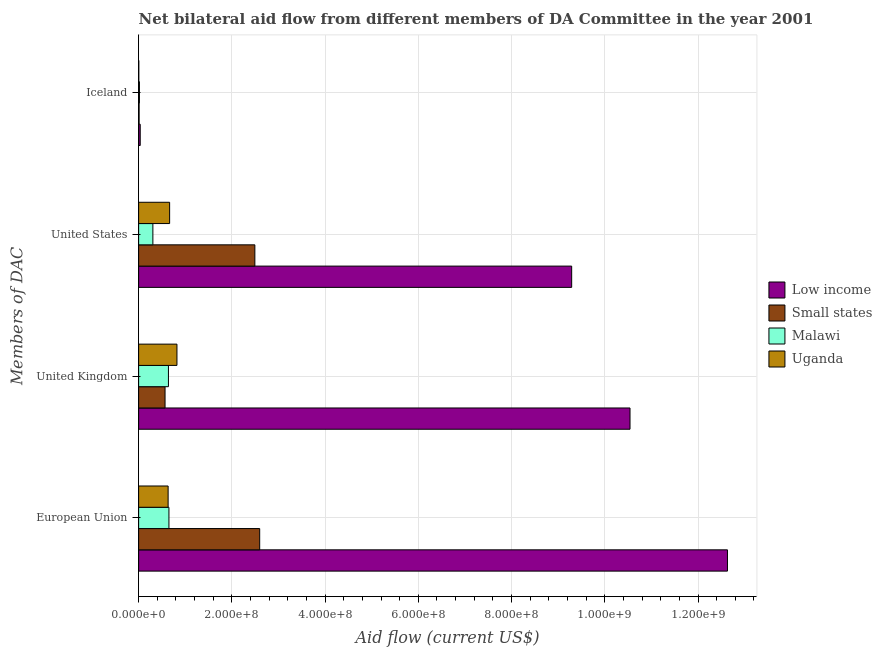How many different coloured bars are there?
Keep it short and to the point. 4. How many groups of bars are there?
Your response must be concise. 4. Are the number of bars per tick equal to the number of legend labels?
Your answer should be compact. Yes. How many bars are there on the 4th tick from the top?
Keep it short and to the point. 4. How many bars are there on the 4th tick from the bottom?
Provide a short and direct response. 4. What is the label of the 2nd group of bars from the top?
Your answer should be very brief. United States. What is the amount of aid given by us in Malawi?
Ensure brevity in your answer.  3.06e+07. Across all countries, what is the maximum amount of aid given by uk?
Keep it short and to the point. 1.05e+09. Across all countries, what is the minimum amount of aid given by us?
Offer a very short reply. 3.06e+07. In which country was the amount of aid given by iceland minimum?
Provide a short and direct response. Uganda. What is the total amount of aid given by iceland in the graph?
Provide a succinct answer. 6.53e+06. What is the difference between the amount of aid given by iceland in Malawi and that in Low income?
Make the answer very short. -1.66e+06. What is the difference between the amount of aid given by iceland in Uganda and the amount of aid given by uk in Low income?
Keep it short and to the point. -1.05e+09. What is the average amount of aid given by eu per country?
Keep it short and to the point. 4.13e+08. What is the difference between the amount of aid given by eu and amount of aid given by us in Low income?
Keep it short and to the point. 3.34e+08. What is the ratio of the amount of aid given by us in Low income to that in Uganda?
Your answer should be compact. 13.97. Is the amount of aid given by uk in Small states less than that in Uganda?
Ensure brevity in your answer.  Yes. What is the difference between the highest and the second highest amount of aid given by iceland?
Ensure brevity in your answer.  1.66e+06. What is the difference between the highest and the lowest amount of aid given by eu?
Provide a short and direct response. 1.20e+09. In how many countries, is the amount of aid given by iceland greater than the average amount of aid given by iceland taken over all countries?
Your answer should be compact. 2. What does the 2nd bar from the top in Iceland represents?
Give a very brief answer. Malawi. What does the 2nd bar from the bottom in Iceland represents?
Make the answer very short. Small states. Is it the case that in every country, the sum of the amount of aid given by eu and amount of aid given by uk is greater than the amount of aid given by us?
Ensure brevity in your answer.  Yes. Are all the bars in the graph horizontal?
Provide a succinct answer. Yes. What is the difference between two consecutive major ticks on the X-axis?
Ensure brevity in your answer.  2.00e+08. Are the values on the major ticks of X-axis written in scientific E-notation?
Your answer should be very brief. Yes. Does the graph contain any zero values?
Your answer should be very brief. No. Does the graph contain grids?
Ensure brevity in your answer.  Yes. Where does the legend appear in the graph?
Give a very brief answer. Center right. What is the title of the graph?
Make the answer very short. Net bilateral aid flow from different members of DA Committee in the year 2001. What is the label or title of the Y-axis?
Give a very brief answer. Members of DAC. What is the Aid flow (current US$) of Low income in European Union?
Your response must be concise. 1.26e+09. What is the Aid flow (current US$) in Small states in European Union?
Your answer should be very brief. 2.60e+08. What is the Aid flow (current US$) in Malawi in European Union?
Your answer should be compact. 6.50e+07. What is the Aid flow (current US$) in Uganda in European Union?
Your answer should be compact. 6.33e+07. What is the Aid flow (current US$) of Low income in United Kingdom?
Your answer should be very brief. 1.05e+09. What is the Aid flow (current US$) of Small states in United Kingdom?
Offer a very short reply. 5.67e+07. What is the Aid flow (current US$) of Malawi in United Kingdom?
Your response must be concise. 6.39e+07. What is the Aid flow (current US$) in Uganda in United Kingdom?
Offer a very short reply. 8.22e+07. What is the Aid flow (current US$) in Low income in United States?
Offer a terse response. 9.29e+08. What is the Aid flow (current US$) of Small states in United States?
Offer a terse response. 2.49e+08. What is the Aid flow (current US$) in Malawi in United States?
Offer a very short reply. 3.06e+07. What is the Aid flow (current US$) in Uganda in United States?
Make the answer very short. 6.65e+07. What is the Aid flow (current US$) of Low income in Iceland?
Provide a short and direct response. 3.40e+06. What is the Aid flow (current US$) in Small states in Iceland?
Offer a very short reply. 1.03e+06. What is the Aid flow (current US$) in Malawi in Iceland?
Keep it short and to the point. 1.74e+06. Across all Members of DAC, what is the maximum Aid flow (current US$) in Low income?
Provide a succinct answer. 1.26e+09. Across all Members of DAC, what is the maximum Aid flow (current US$) in Small states?
Provide a short and direct response. 2.60e+08. Across all Members of DAC, what is the maximum Aid flow (current US$) of Malawi?
Make the answer very short. 6.50e+07. Across all Members of DAC, what is the maximum Aid flow (current US$) of Uganda?
Make the answer very short. 8.22e+07. Across all Members of DAC, what is the minimum Aid flow (current US$) in Low income?
Offer a very short reply. 3.40e+06. Across all Members of DAC, what is the minimum Aid flow (current US$) of Small states?
Offer a terse response. 1.03e+06. Across all Members of DAC, what is the minimum Aid flow (current US$) in Malawi?
Provide a short and direct response. 1.74e+06. Across all Members of DAC, what is the minimum Aid flow (current US$) in Uganda?
Your response must be concise. 3.60e+05. What is the total Aid flow (current US$) in Low income in the graph?
Make the answer very short. 3.25e+09. What is the total Aid flow (current US$) of Small states in the graph?
Provide a succinct answer. 5.67e+08. What is the total Aid flow (current US$) of Malawi in the graph?
Provide a succinct answer. 1.61e+08. What is the total Aid flow (current US$) in Uganda in the graph?
Your answer should be very brief. 2.12e+08. What is the difference between the Aid flow (current US$) of Low income in European Union and that in United Kingdom?
Offer a very short reply. 2.09e+08. What is the difference between the Aid flow (current US$) of Small states in European Union and that in United Kingdom?
Your answer should be very brief. 2.03e+08. What is the difference between the Aid flow (current US$) in Malawi in European Union and that in United Kingdom?
Provide a succinct answer. 1.08e+06. What is the difference between the Aid flow (current US$) in Uganda in European Union and that in United Kingdom?
Give a very brief answer. -1.90e+07. What is the difference between the Aid flow (current US$) of Low income in European Union and that in United States?
Your answer should be compact. 3.34e+08. What is the difference between the Aid flow (current US$) in Small states in European Union and that in United States?
Ensure brevity in your answer.  1.04e+07. What is the difference between the Aid flow (current US$) of Malawi in European Union and that in United States?
Offer a very short reply. 3.45e+07. What is the difference between the Aid flow (current US$) of Uganda in European Union and that in United States?
Make the answer very short. -3.21e+06. What is the difference between the Aid flow (current US$) in Low income in European Union and that in Iceland?
Provide a short and direct response. 1.26e+09. What is the difference between the Aid flow (current US$) of Small states in European Union and that in Iceland?
Keep it short and to the point. 2.59e+08. What is the difference between the Aid flow (current US$) in Malawi in European Union and that in Iceland?
Your answer should be very brief. 6.33e+07. What is the difference between the Aid flow (current US$) of Uganda in European Union and that in Iceland?
Make the answer very short. 6.29e+07. What is the difference between the Aid flow (current US$) of Low income in United Kingdom and that in United States?
Provide a short and direct response. 1.25e+08. What is the difference between the Aid flow (current US$) of Small states in United Kingdom and that in United States?
Give a very brief answer. -1.93e+08. What is the difference between the Aid flow (current US$) in Malawi in United Kingdom and that in United States?
Offer a very short reply. 3.34e+07. What is the difference between the Aid flow (current US$) of Uganda in United Kingdom and that in United States?
Provide a short and direct response. 1.57e+07. What is the difference between the Aid flow (current US$) in Low income in United Kingdom and that in Iceland?
Your answer should be very brief. 1.05e+09. What is the difference between the Aid flow (current US$) of Small states in United Kingdom and that in Iceland?
Give a very brief answer. 5.56e+07. What is the difference between the Aid flow (current US$) of Malawi in United Kingdom and that in Iceland?
Offer a very short reply. 6.22e+07. What is the difference between the Aid flow (current US$) in Uganda in United Kingdom and that in Iceland?
Offer a very short reply. 8.19e+07. What is the difference between the Aid flow (current US$) in Low income in United States and that in Iceland?
Provide a short and direct response. 9.26e+08. What is the difference between the Aid flow (current US$) of Small states in United States and that in Iceland?
Your answer should be compact. 2.48e+08. What is the difference between the Aid flow (current US$) in Malawi in United States and that in Iceland?
Provide a succinct answer. 2.88e+07. What is the difference between the Aid flow (current US$) in Uganda in United States and that in Iceland?
Offer a very short reply. 6.61e+07. What is the difference between the Aid flow (current US$) of Low income in European Union and the Aid flow (current US$) of Small states in United Kingdom?
Your response must be concise. 1.21e+09. What is the difference between the Aid flow (current US$) of Low income in European Union and the Aid flow (current US$) of Malawi in United Kingdom?
Your response must be concise. 1.20e+09. What is the difference between the Aid flow (current US$) in Low income in European Union and the Aid flow (current US$) in Uganda in United Kingdom?
Provide a short and direct response. 1.18e+09. What is the difference between the Aid flow (current US$) in Small states in European Union and the Aid flow (current US$) in Malawi in United Kingdom?
Keep it short and to the point. 1.96e+08. What is the difference between the Aid flow (current US$) in Small states in European Union and the Aid flow (current US$) in Uganda in United Kingdom?
Ensure brevity in your answer.  1.77e+08. What is the difference between the Aid flow (current US$) of Malawi in European Union and the Aid flow (current US$) of Uganda in United Kingdom?
Keep it short and to the point. -1.72e+07. What is the difference between the Aid flow (current US$) of Low income in European Union and the Aid flow (current US$) of Small states in United States?
Offer a terse response. 1.01e+09. What is the difference between the Aid flow (current US$) of Low income in European Union and the Aid flow (current US$) of Malawi in United States?
Your answer should be compact. 1.23e+09. What is the difference between the Aid flow (current US$) in Low income in European Union and the Aid flow (current US$) in Uganda in United States?
Provide a succinct answer. 1.20e+09. What is the difference between the Aid flow (current US$) in Small states in European Union and the Aid flow (current US$) in Malawi in United States?
Ensure brevity in your answer.  2.29e+08. What is the difference between the Aid flow (current US$) in Small states in European Union and the Aid flow (current US$) in Uganda in United States?
Ensure brevity in your answer.  1.93e+08. What is the difference between the Aid flow (current US$) in Malawi in European Union and the Aid flow (current US$) in Uganda in United States?
Give a very brief answer. -1.46e+06. What is the difference between the Aid flow (current US$) of Low income in European Union and the Aid flow (current US$) of Small states in Iceland?
Ensure brevity in your answer.  1.26e+09. What is the difference between the Aid flow (current US$) in Low income in European Union and the Aid flow (current US$) in Malawi in Iceland?
Provide a short and direct response. 1.26e+09. What is the difference between the Aid flow (current US$) of Low income in European Union and the Aid flow (current US$) of Uganda in Iceland?
Your response must be concise. 1.26e+09. What is the difference between the Aid flow (current US$) in Small states in European Union and the Aid flow (current US$) in Malawi in Iceland?
Your answer should be very brief. 2.58e+08. What is the difference between the Aid flow (current US$) of Small states in European Union and the Aid flow (current US$) of Uganda in Iceland?
Your answer should be compact. 2.59e+08. What is the difference between the Aid flow (current US$) of Malawi in European Union and the Aid flow (current US$) of Uganda in Iceland?
Your response must be concise. 6.47e+07. What is the difference between the Aid flow (current US$) of Low income in United Kingdom and the Aid flow (current US$) of Small states in United States?
Offer a terse response. 8.05e+08. What is the difference between the Aid flow (current US$) in Low income in United Kingdom and the Aid flow (current US$) in Malawi in United States?
Keep it short and to the point. 1.02e+09. What is the difference between the Aid flow (current US$) in Low income in United Kingdom and the Aid flow (current US$) in Uganda in United States?
Offer a terse response. 9.88e+08. What is the difference between the Aid flow (current US$) of Small states in United Kingdom and the Aid flow (current US$) of Malawi in United States?
Offer a very short reply. 2.61e+07. What is the difference between the Aid flow (current US$) of Small states in United Kingdom and the Aid flow (current US$) of Uganda in United States?
Keep it short and to the point. -9.80e+06. What is the difference between the Aid flow (current US$) in Malawi in United Kingdom and the Aid flow (current US$) in Uganda in United States?
Provide a succinct answer. -2.54e+06. What is the difference between the Aid flow (current US$) of Low income in United Kingdom and the Aid flow (current US$) of Small states in Iceland?
Provide a succinct answer. 1.05e+09. What is the difference between the Aid flow (current US$) of Low income in United Kingdom and the Aid flow (current US$) of Malawi in Iceland?
Your answer should be very brief. 1.05e+09. What is the difference between the Aid flow (current US$) in Low income in United Kingdom and the Aid flow (current US$) in Uganda in Iceland?
Your response must be concise. 1.05e+09. What is the difference between the Aid flow (current US$) of Small states in United Kingdom and the Aid flow (current US$) of Malawi in Iceland?
Offer a terse response. 5.49e+07. What is the difference between the Aid flow (current US$) in Small states in United Kingdom and the Aid flow (current US$) in Uganda in Iceland?
Give a very brief answer. 5.63e+07. What is the difference between the Aid flow (current US$) of Malawi in United Kingdom and the Aid flow (current US$) of Uganda in Iceland?
Offer a very short reply. 6.36e+07. What is the difference between the Aid flow (current US$) in Low income in United States and the Aid flow (current US$) in Small states in Iceland?
Give a very brief answer. 9.28e+08. What is the difference between the Aid flow (current US$) in Low income in United States and the Aid flow (current US$) in Malawi in Iceland?
Offer a very short reply. 9.27e+08. What is the difference between the Aid flow (current US$) in Low income in United States and the Aid flow (current US$) in Uganda in Iceland?
Provide a succinct answer. 9.29e+08. What is the difference between the Aid flow (current US$) of Small states in United States and the Aid flow (current US$) of Malawi in Iceland?
Your answer should be very brief. 2.48e+08. What is the difference between the Aid flow (current US$) of Small states in United States and the Aid flow (current US$) of Uganda in Iceland?
Your response must be concise. 2.49e+08. What is the difference between the Aid flow (current US$) in Malawi in United States and the Aid flow (current US$) in Uganda in Iceland?
Make the answer very short. 3.02e+07. What is the average Aid flow (current US$) in Low income per Members of DAC?
Your answer should be very brief. 8.12e+08. What is the average Aid flow (current US$) in Small states per Members of DAC?
Give a very brief answer. 1.42e+08. What is the average Aid flow (current US$) in Malawi per Members of DAC?
Provide a short and direct response. 4.03e+07. What is the average Aid flow (current US$) in Uganda per Members of DAC?
Provide a short and direct response. 5.31e+07. What is the difference between the Aid flow (current US$) of Low income and Aid flow (current US$) of Small states in European Union?
Offer a terse response. 1.00e+09. What is the difference between the Aid flow (current US$) of Low income and Aid flow (current US$) of Malawi in European Union?
Give a very brief answer. 1.20e+09. What is the difference between the Aid flow (current US$) of Low income and Aid flow (current US$) of Uganda in European Union?
Make the answer very short. 1.20e+09. What is the difference between the Aid flow (current US$) of Small states and Aid flow (current US$) of Malawi in European Union?
Make the answer very short. 1.95e+08. What is the difference between the Aid flow (current US$) in Small states and Aid flow (current US$) in Uganda in European Union?
Give a very brief answer. 1.96e+08. What is the difference between the Aid flow (current US$) of Malawi and Aid flow (current US$) of Uganda in European Union?
Your response must be concise. 1.75e+06. What is the difference between the Aid flow (current US$) in Low income and Aid flow (current US$) in Small states in United Kingdom?
Your answer should be very brief. 9.97e+08. What is the difference between the Aid flow (current US$) in Low income and Aid flow (current US$) in Malawi in United Kingdom?
Provide a succinct answer. 9.90e+08. What is the difference between the Aid flow (current US$) of Low income and Aid flow (current US$) of Uganda in United Kingdom?
Keep it short and to the point. 9.72e+08. What is the difference between the Aid flow (current US$) of Small states and Aid flow (current US$) of Malawi in United Kingdom?
Keep it short and to the point. -7.26e+06. What is the difference between the Aid flow (current US$) of Small states and Aid flow (current US$) of Uganda in United Kingdom?
Provide a short and direct response. -2.55e+07. What is the difference between the Aid flow (current US$) in Malawi and Aid flow (current US$) in Uganda in United Kingdom?
Offer a terse response. -1.83e+07. What is the difference between the Aid flow (current US$) in Low income and Aid flow (current US$) in Small states in United States?
Your response must be concise. 6.80e+08. What is the difference between the Aid flow (current US$) in Low income and Aid flow (current US$) in Malawi in United States?
Your answer should be compact. 8.98e+08. What is the difference between the Aid flow (current US$) of Low income and Aid flow (current US$) of Uganda in United States?
Make the answer very short. 8.62e+08. What is the difference between the Aid flow (current US$) in Small states and Aid flow (current US$) in Malawi in United States?
Offer a very short reply. 2.19e+08. What is the difference between the Aid flow (current US$) of Small states and Aid flow (current US$) of Uganda in United States?
Provide a succinct answer. 1.83e+08. What is the difference between the Aid flow (current US$) in Malawi and Aid flow (current US$) in Uganda in United States?
Provide a short and direct response. -3.59e+07. What is the difference between the Aid flow (current US$) in Low income and Aid flow (current US$) in Small states in Iceland?
Offer a very short reply. 2.37e+06. What is the difference between the Aid flow (current US$) in Low income and Aid flow (current US$) in Malawi in Iceland?
Your answer should be very brief. 1.66e+06. What is the difference between the Aid flow (current US$) of Low income and Aid flow (current US$) of Uganda in Iceland?
Offer a very short reply. 3.04e+06. What is the difference between the Aid flow (current US$) in Small states and Aid flow (current US$) in Malawi in Iceland?
Give a very brief answer. -7.10e+05. What is the difference between the Aid flow (current US$) of Small states and Aid flow (current US$) of Uganda in Iceland?
Your answer should be very brief. 6.70e+05. What is the difference between the Aid flow (current US$) of Malawi and Aid flow (current US$) of Uganda in Iceland?
Offer a very short reply. 1.38e+06. What is the ratio of the Aid flow (current US$) of Low income in European Union to that in United Kingdom?
Your answer should be very brief. 1.2. What is the ratio of the Aid flow (current US$) in Small states in European Union to that in United Kingdom?
Your answer should be compact. 4.58. What is the ratio of the Aid flow (current US$) of Malawi in European Union to that in United Kingdom?
Give a very brief answer. 1.02. What is the ratio of the Aid flow (current US$) of Uganda in European Union to that in United Kingdom?
Make the answer very short. 0.77. What is the ratio of the Aid flow (current US$) in Low income in European Union to that in United States?
Your answer should be compact. 1.36. What is the ratio of the Aid flow (current US$) in Small states in European Union to that in United States?
Offer a terse response. 1.04. What is the ratio of the Aid flow (current US$) of Malawi in European Union to that in United States?
Offer a terse response. 2.13. What is the ratio of the Aid flow (current US$) in Uganda in European Union to that in United States?
Provide a succinct answer. 0.95. What is the ratio of the Aid flow (current US$) in Low income in European Union to that in Iceland?
Your response must be concise. 371.51. What is the ratio of the Aid flow (current US$) of Small states in European Union to that in Iceland?
Your answer should be compact. 252.13. What is the ratio of the Aid flow (current US$) of Malawi in European Union to that in Iceland?
Your answer should be compact. 37.37. What is the ratio of the Aid flow (current US$) in Uganda in European Union to that in Iceland?
Make the answer very short. 175.75. What is the ratio of the Aid flow (current US$) in Low income in United Kingdom to that in United States?
Provide a succinct answer. 1.13. What is the ratio of the Aid flow (current US$) in Small states in United Kingdom to that in United States?
Your answer should be compact. 0.23. What is the ratio of the Aid flow (current US$) of Malawi in United Kingdom to that in United States?
Make the answer very short. 2.09. What is the ratio of the Aid flow (current US$) in Uganda in United Kingdom to that in United States?
Your answer should be very brief. 1.24. What is the ratio of the Aid flow (current US$) in Low income in United Kingdom to that in Iceland?
Give a very brief answer. 310.02. What is the ratio of the Aid flow (current US$) of Small states in United Kingdom to that in Iceland?
Your answer should be compact. 55.03. What is the ratio of the Aid flow (current US$) of Malawi in United Kingdom to that in Iceland?
Offer a very short reply. 36.75. What is the ratio of the Aid flow (current US$) in Uganda in United Kingdom to that in Iceland?
Your answer should be very brief. 228.39. What is the ratio of the Aid flow (current US$) of Low income in United States to that in Iceland?
Make the answer very short. 273.22. What is the ratio of the Aid flow (current US$) in Small states in United States to that in Iceland?
Offer a very short reply. 242.07. What is the ratio of the Aid flow (current US$) of Malawi in United States to that in Iceland?
Ensure brevity in your answer.  17.56. What is the ratio of the Aid flow (current US$) of Uganda in United States to that in Iceland?
Provide a short and direct response. 184.67. What is the difference between the highest and the second highest Aid flow (current US$) in Low income?
Your answer should be compact. 2.09e+08. What is the difference between the highest and the second highest Aid flow (current US$) in Small states?
Make the answer very short. 1.04e+07. What is the difference between the highest and the second highest Aid flow (current US$) in Malawi?
Your answer should be very brief. 1.08e+06. What is the difference between the highest and the second highest Aid flow (current US$) in Uganda?
Ensure brevity in your answer.  1.57e+07. What is the difference between the highest and the lowest Aid flow (current US$) of Low income?
Your answer should be compact. 1.26e+09. What is the difference between the highest and the lowest Aid flow (current US$) in Small states?
Your response must be concise. 2.59e+08. What is the difference between the highest and the lowest Aid flow (current US$) of Malawi?
Your answer should be compact. 6.33e+07. What is the difference between the highest and the lowest Aid flow (current US$) in Uganda?
Your answer should be compact. 8.19e+07. 